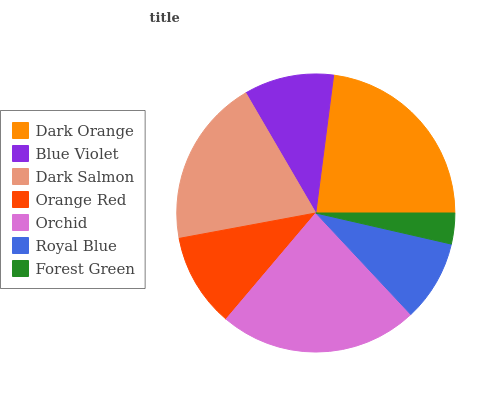Is Forest Green the minimum?
Answer yes or no. Yes. Is Orchid the maximum?
Answer yes or no. Yes. Is Blue Violet the minimum?
Answer yes or no. No. Is Blue Violet the maximum?
Answer yes or no. No. Is Dark Orange greater than Blue Violet?
Answer yes or no. Yes. Is Blue Violet less than Dark Orange?
Answer yes or no. Yes. Is Blue Violet greater than Dark Orange?
Answer yes or no. No. Is Dark Orange less than Blue Violet?
Answer yes or no. No. Is Orange Red the high median?
Answer yes or no. Yes. Is Orange Red the low median?
Answer yes or no. Yes. Is Orchid the high median?
Answer yes or no. No. Is Dark Salmon the low median?
Answer yes or no. No. 